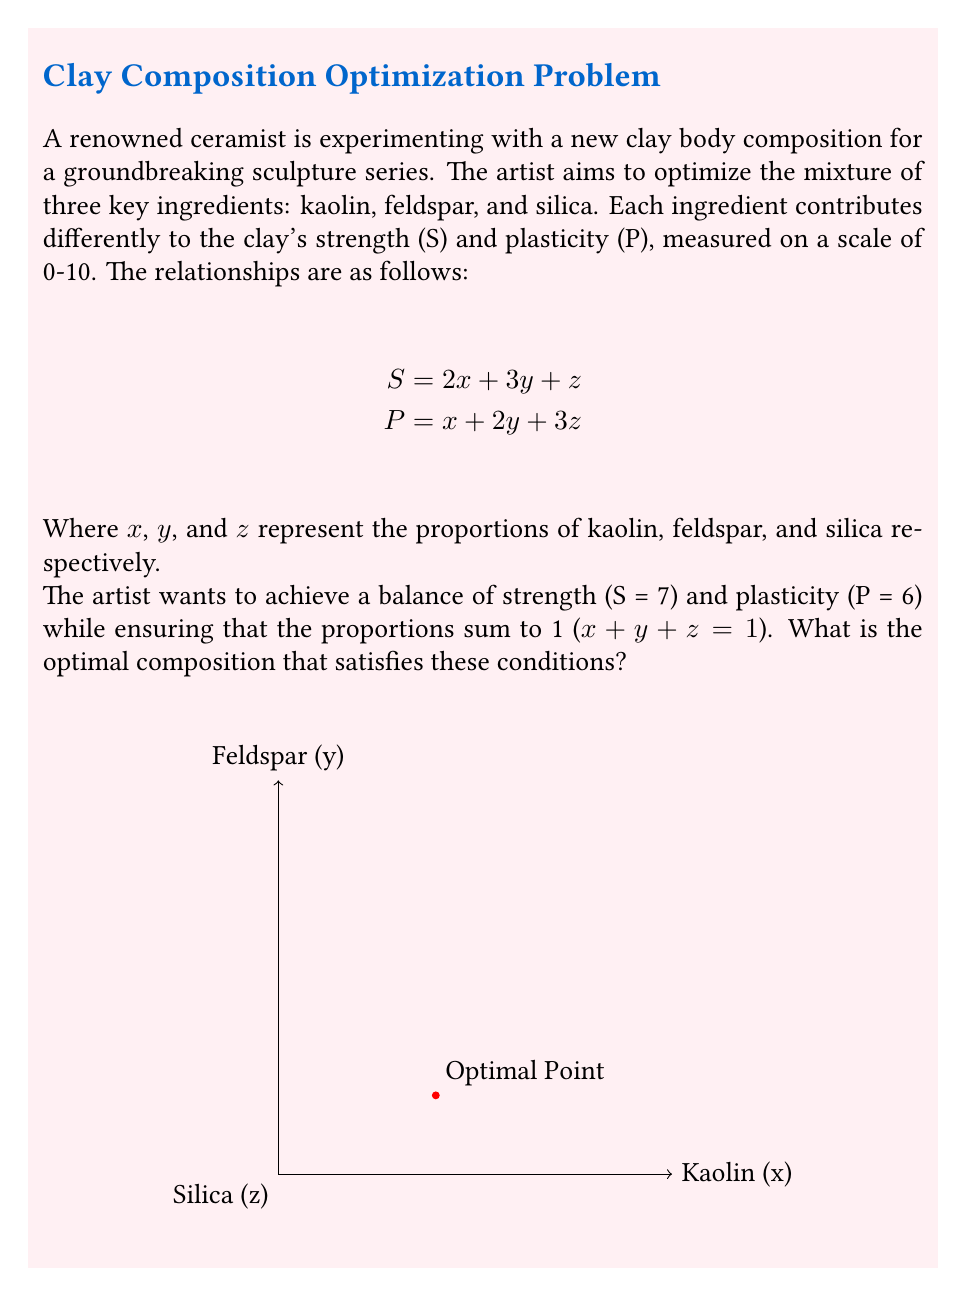Teach me how to tackle this problem. To solve this optimization problem, we need to set up a system of linear equations based on the given conditions:

1) Strength equation: $S = 2x + 3y + z = 7$
2) Plasticity equation: $P = x + 2y + 3z = 6$
3) Sum of proportions: $x + y + z = 1$

Now, let's solve this system of equations:

Step 1: Subtract equation (2) from equation (1):
$$(2x + 3y + z) - (x + 2y + 3z) = 7 - 6$$
$$x + y - 2z = 1$$

Step 2: Multiply equation (3) by 2 and subtract from equation (1):
$$(2x + 3y + z) - 2(x + y + z) = 7 - 2$$
$$y - z = 5$$

Step 3: From Step 2, we can express y in terms of z:
$$y = z + 5$$

Step 4: Substitute this into equation (3):
$$x + (z + 5) + z = 1$$
$$x + 2z = -4$$

Step 5: Express x in terms of z:
$$x = -4 - 2z$$

Step 6: Substitute the expressions for x and y into equation (2):
$$(-4 - 2z) + 2(z + 5) + 3z = 6$$
$$-4 - 2z + 2z + 10 + 3z = 6$$
$$6 + 3z = 6$$
$$3z = 0$$
$$z = 0$$

Step 7: Now we can find y and x:
$$y = z + 5 = 0 + 5 = 5$$
$$x = -4 - 2z = -4 - 2(0) = -4$$

Therefore, the optimal composition is:
Kaolin (x) = 0.4
Feldspar (y) = 0.5
Silica (z) = 0.1
Answer: (0.4, 0.5, 0.1) 